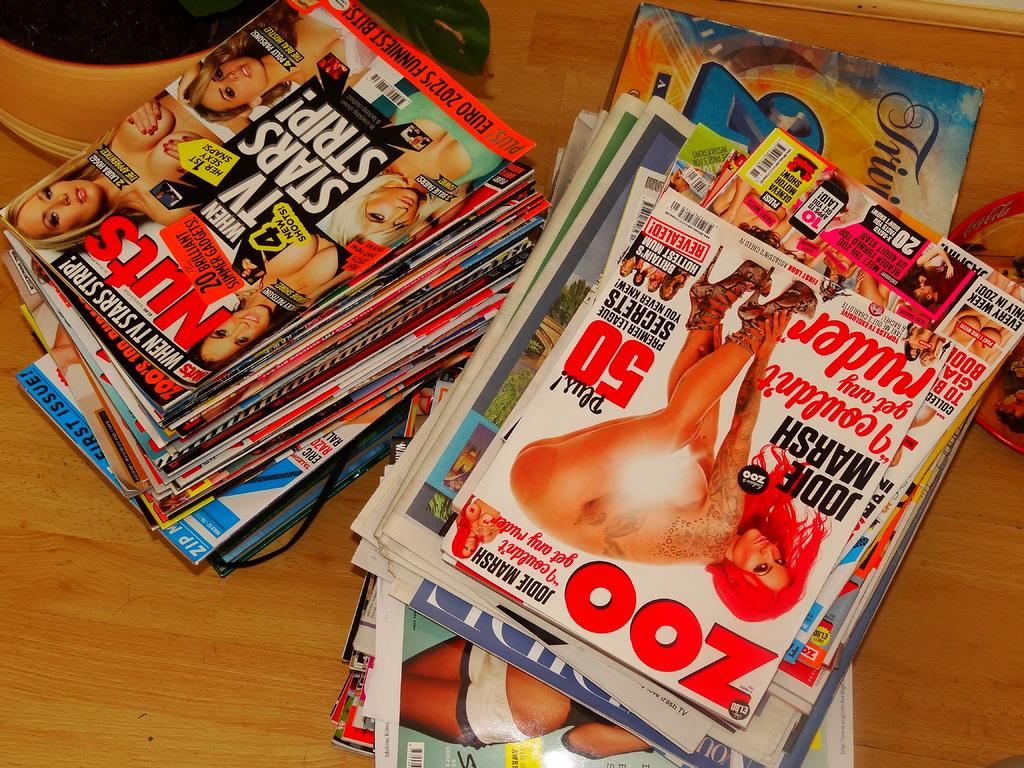<image>
Create a compact narrative representing the image presented. A stack of pornographic magazines includes a copy of Nuts. 